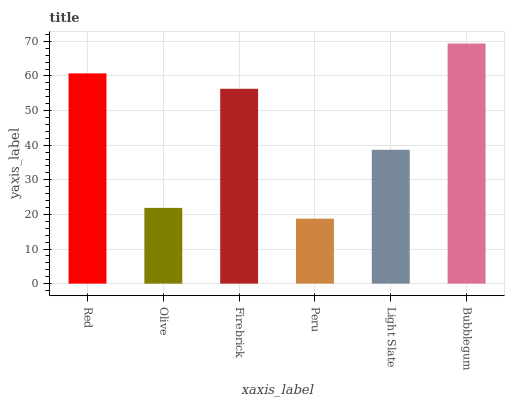Is Peru the minimum?
Answer yes or no. Yes. Is Bubblegum the maximum?
Answer yes or no. Yes. Is Olive the minimum?
Answer yes or no. No. Is Olive the maximum?
Answer yes or no. No. Is Red greater than Olive?
Answer yes or no. Yes. Is Olive less than Red?
Answer yes or no. Yes. Is Olive greater than Red?
Answer yes or no. No. Is Red less than Olive?
Answer yes or no. No. Is Firebrick the high median?
Answer yes or no. Yes. Is Light Slate the low median?
Answer yes or no. Yes. Is Bubblegum the high median?
Answer yes or no. No. Is Red the low median?
Answer yes or no. No. 